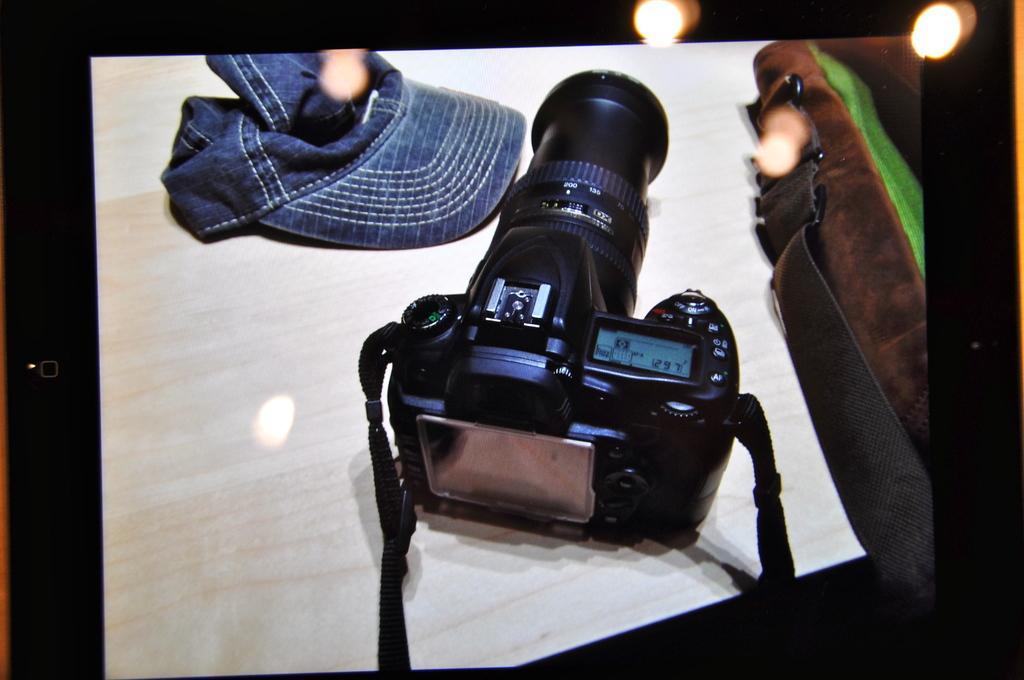Can you describe this image briefly? In the picture we can see a camera on the table. There is a cap and a bag on the table. We can see lights.  